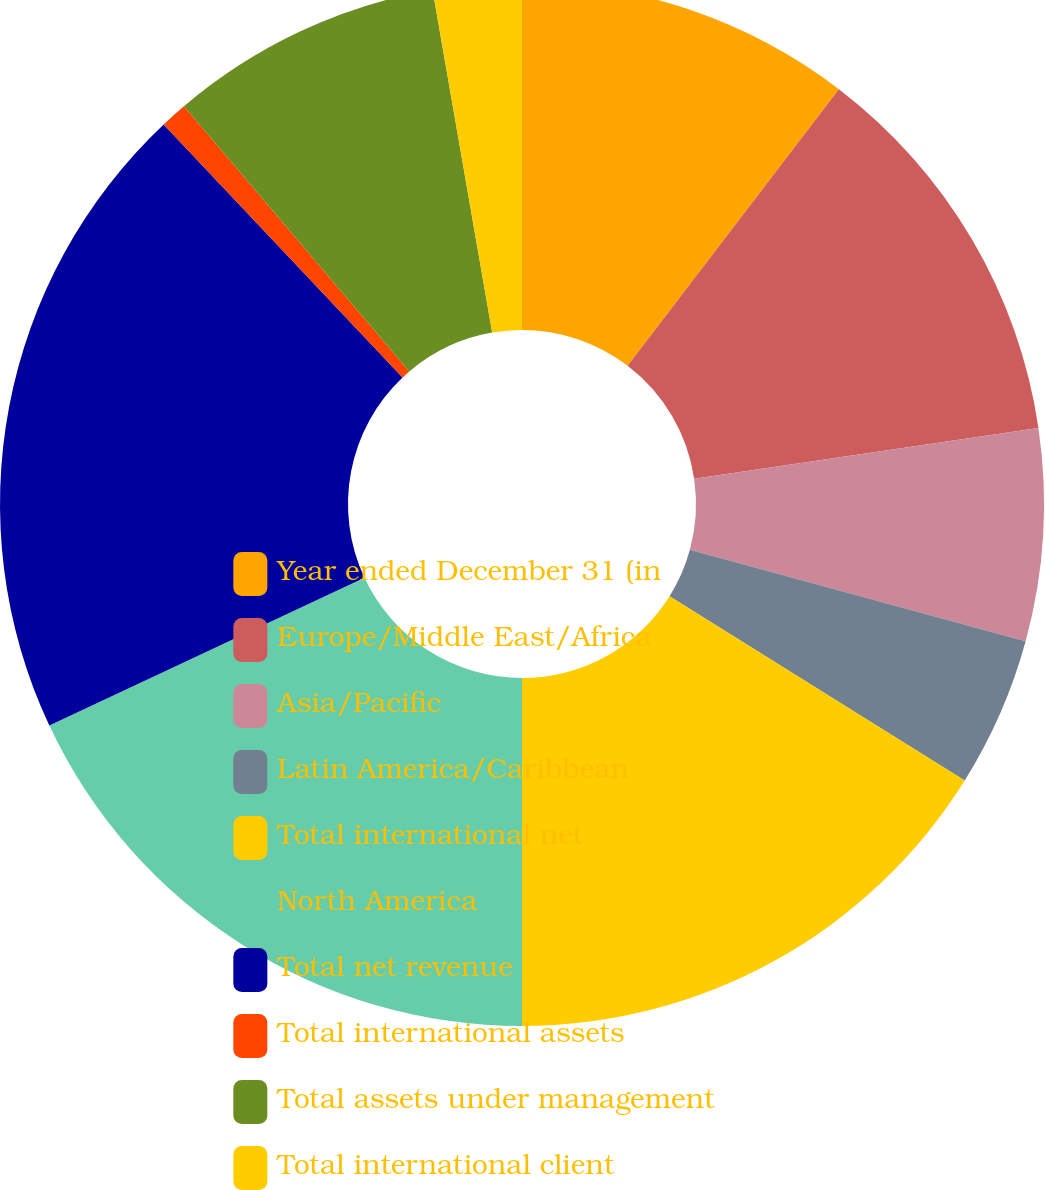Convert chart to OTSL. <chart><loc_0><loc_0><loc_500><loc_500><pie_chart><fcel>Year ended December 31 (in<fcel>Europe/Middle East/Africa<fcel>Asia/Pacific<fcel>Latin America/Caribbean<fcel>Total international net<fcel>North America<fcel>Total net revenue<fcel>Total international assets<fcel>Total assets under management<fcel>Total international client<nl><fcel>10.38%<fcel>12.29%<fcel>6.56%<fcel>4.65%<fcel>16.11%<fcel>18.02%<fcel>19.93%<fcel>0.83%<fcel>8.47%<fcel>2.74%<nl></chart> 